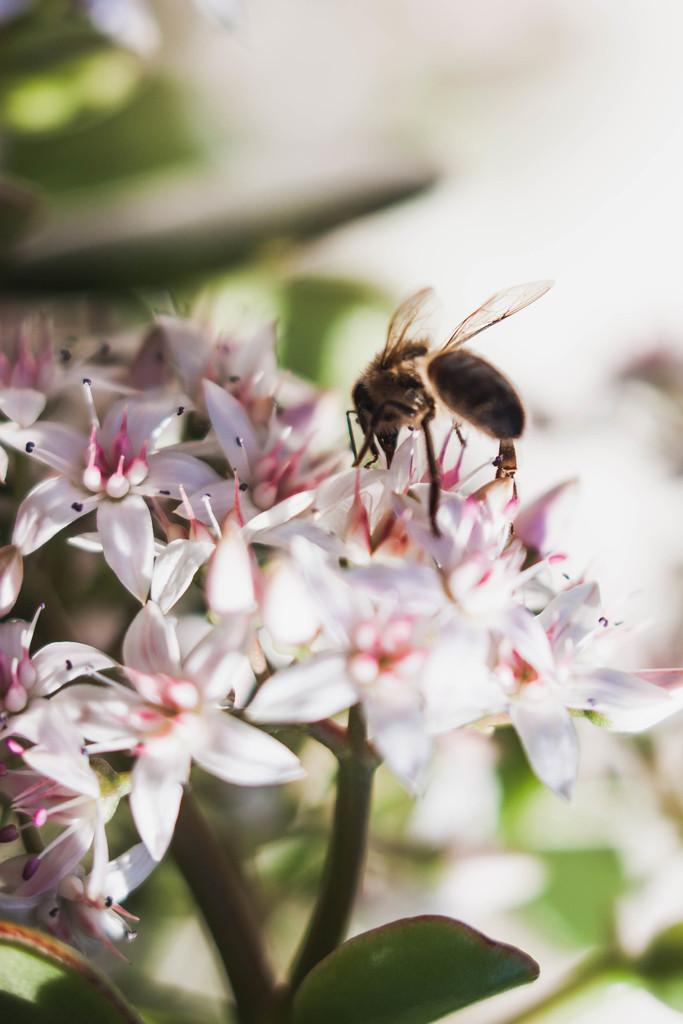What type of insect can be seen in the image? There is a honey bee on the flowers in the image. What type of plants are in the image? There are flowers in the image. What parts of the plants are visible in the image? Leaves and stems are visible in the image. How would you describe the background of the image? The background has a blurred view. What type of egg is being prepared in the office in the image? There is no egg or office present in the image; it features a honey bee on flowers with leaves and stems in the background. 